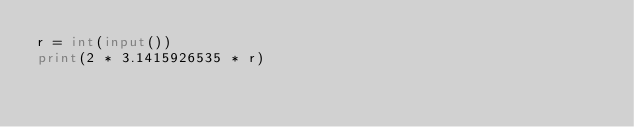<code> <loc_0><loc_0><loc_500><loc_500><_Python_>r = int(input())
print(2 * 3.1415926535 * r)</code> 